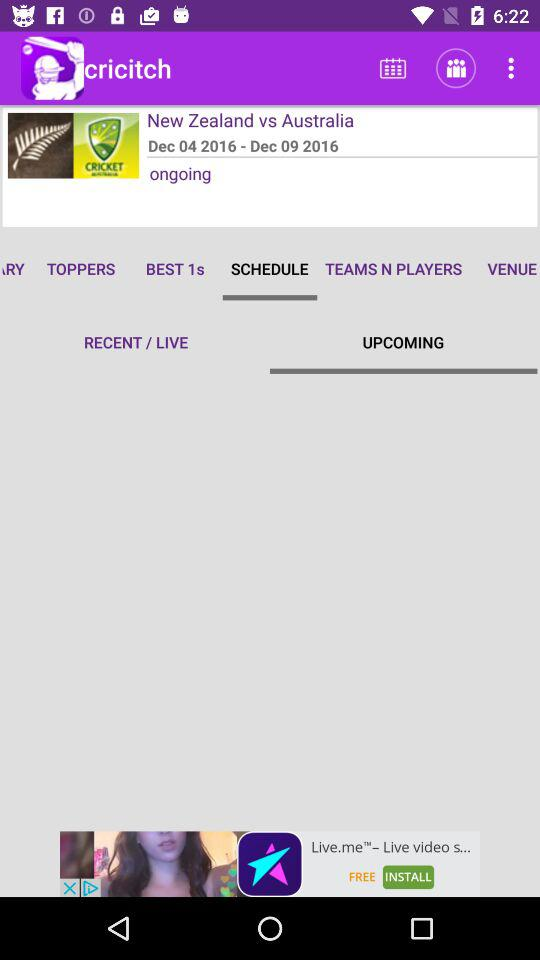What are the selected tabs? The selected tabs are "SCHEDULE" and "UPCOMING". 